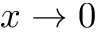<formula> <loc_0><loc_0><loc_500><loc_500>x \to 0</formula> 